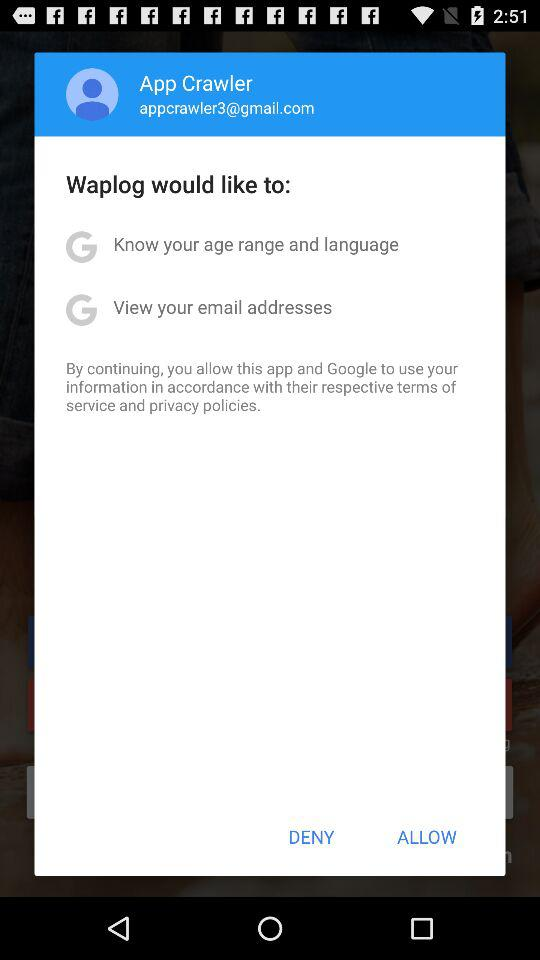How many permissions are being requested by Waplog?
Answer the question using a single word or phrase. 2 